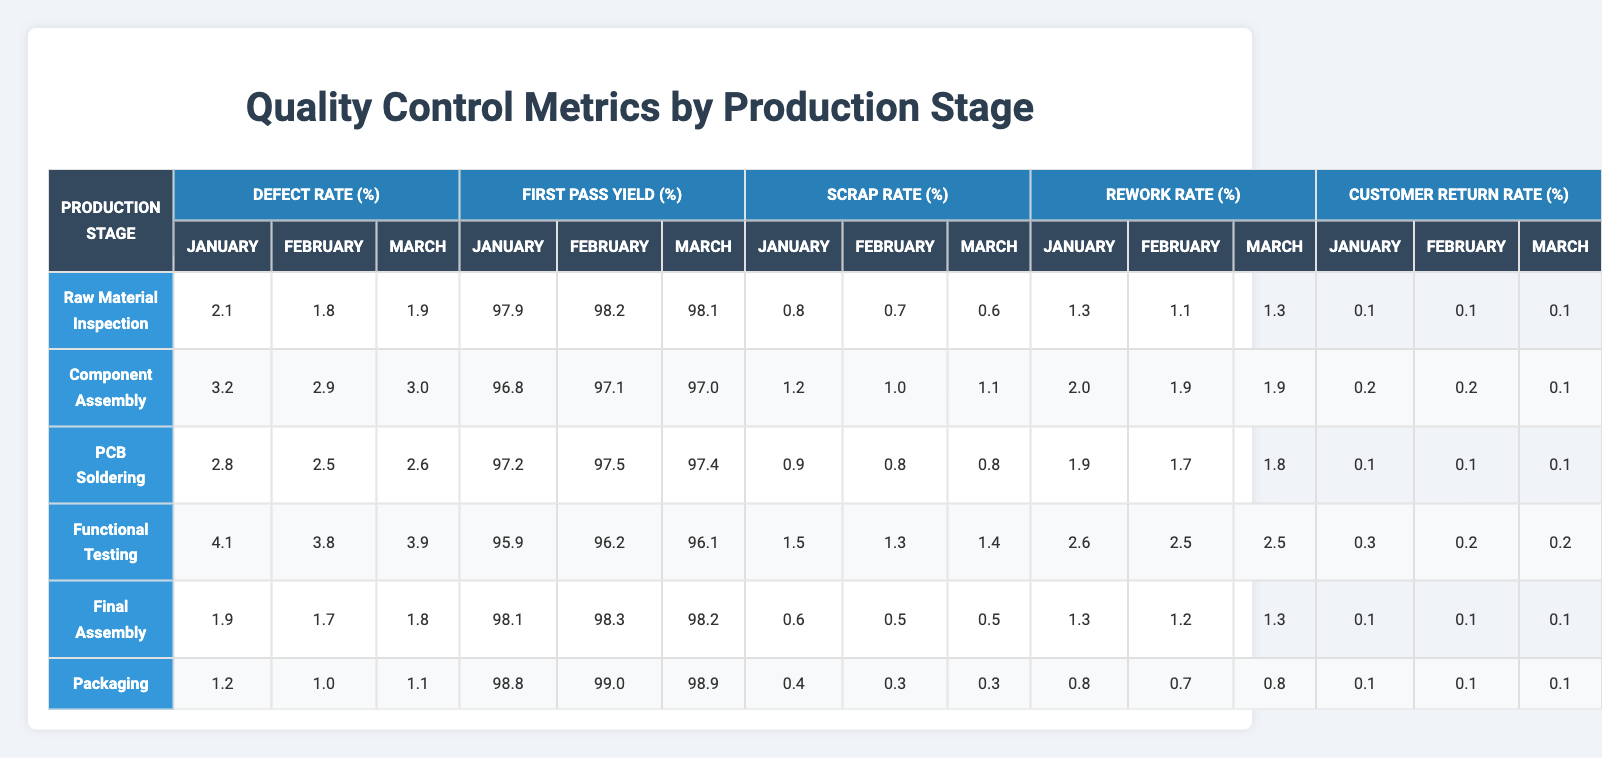What was the highest defect rate in January? In January, the defect rates for each stage are as follows: Raw Material Inspection (2.1%), Component Assembly (3.2%), PCB Soldering (2.8%), Functional Testing (4.1%), Final Assembly (1.9%), and Packaging (1.2%). The highest value is 4.1% from Functional Testing.
Answer: 4.1% What was the first pass yield percentage for the Component Assembly in February? The table shows that for Component Assembly in February, the First Pass Yield percentage is 97.1%.
Answer: 97.1% What is the average defect rate for PCB Soldering across the three months? The defect rates for PCB Soldering are 2.8% in January, 2.5% in February, and 2.6% in March. To find the average, we sum these rates: 2.8 + 2.5 + 2.6 = 7.9%. Dividing by 3 gives us an average of 7.9/3 = 2.63%.
Answer: 2.63% In which production stage was the First Pass Yield lower than 96% at any point? The only stage where the First Pass Yield fell below 96% is in Functional Testing with a value of 95.9% in January. The other stages consistently have higher percentages across all months.
Answer: Yes What is the trend in the Customer Return Rate from January to March for Functional Testing? In January, the Customer Return Rate is 0.3%, February is 0.2%, and March is also 0.2%. This shows a decrease from January to February and remains the same in March.
Answer: Decrease What is the total rework rate for Raw Material Inspection across the three months? The rework rates for Raw Material Inspection are 1.3% in January, 1.1% in February, and 1.3% in March. To find the total, we sum them: 1.3 + 1.1 + 1.3 = 3.7%.
Answer: 3.7% Which stage had the lowest scrap rate in March? The scrap rates for March are as follows: Raw Material Inspection (0.6%), Component Assembly (1.1%), PCB Soldering (0.8%), Functional Testing (1.4%), Final Assembly (0.5%), and Packaging (0.3%). The lowest is from Packaging at 0.3%.
Answer: Packaging What is the difference in Scrap Rate between the Functional Testing and Final Assembly in February? The scrap rate for Functional Testing in February is 1.3%, while for Final Assembly it is 0.5%. The difference is calculated as 1.3% - 0.5% = 0.8%.
Answer: 0.8% How does the average First Pass Yield for Packaging compare across the three months, and what can we conclude? The First Pass Yield values for Packaging are 98.8% (January), 99.0% (February), and 98.9% (March). The average is (98.8 + 99.0 + 98.9) / 3 = 98.9%. Since all values are high, it shows that Packaging is consistently performing well.
Answer: Consistently high performance Which stage had the highest customer return rate in January? The Customer Return Rates in January are: Raw Material Inspection (0.1%), Component Assembly (0.2%), PCB Soldering (0.1%), Functional Testing (0.3%), Final Assembly (0.1%), and Packaging (0.1%). The highest rate is from Functional Testing at 0.3%.
Answer: Functional Testing 